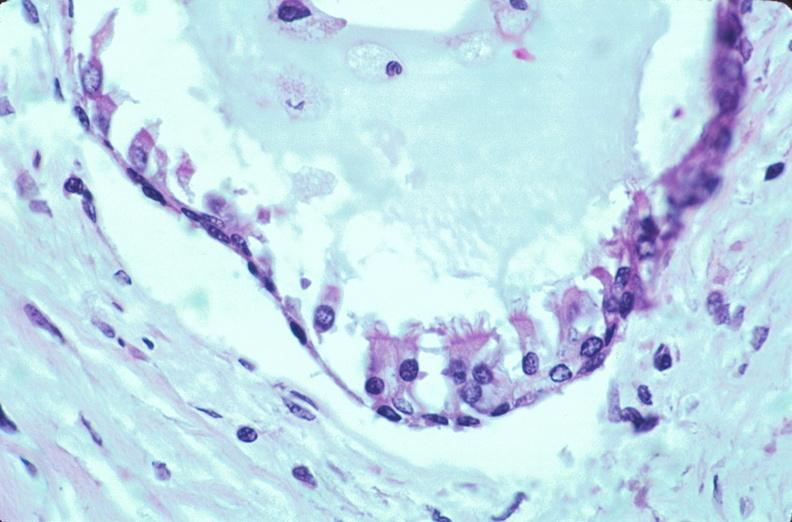what is embryo-fetus?
Answer the question using a single word or phrase. Fetus present 